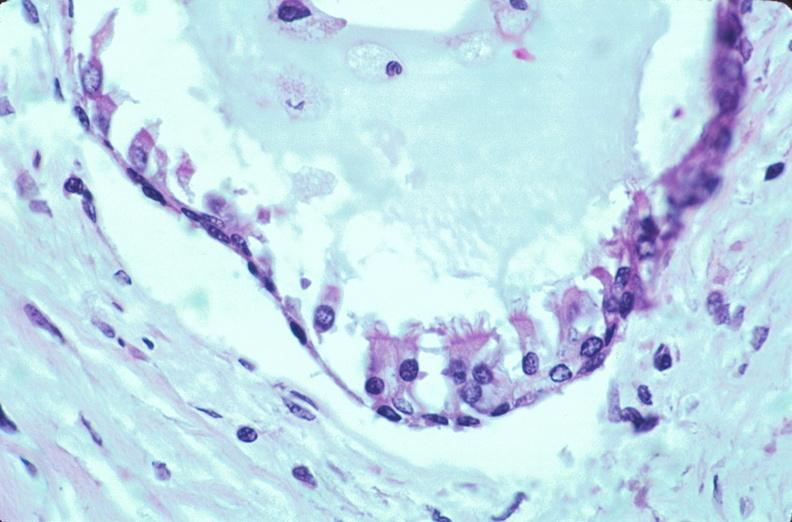what is embryo-fetus?
Answer the question using a single word or phrase. Fetus present 